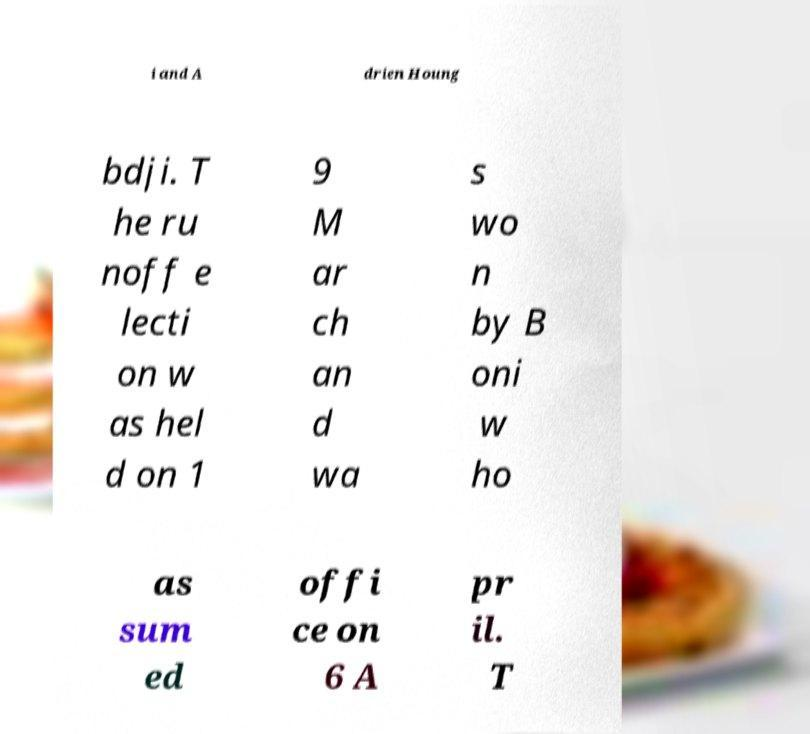Can you accurately transcribe the text from the provided image for me? i and A drien Houng bdji. T he ru noff e lecti on w as hel d on 1 9 M ar ch an d wa s wo n by B oni w ho as sum ed offi ce on 6 A pr il. T 